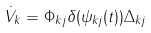Convert formula to latex. <formula><loc_0><loc_0><loc_500><loc_500>\dot { V } _ { k } = \Phi _ { k j } \delta ( \psi _ { k j } ( t ) ) \Delta _ { k j }</formula> 